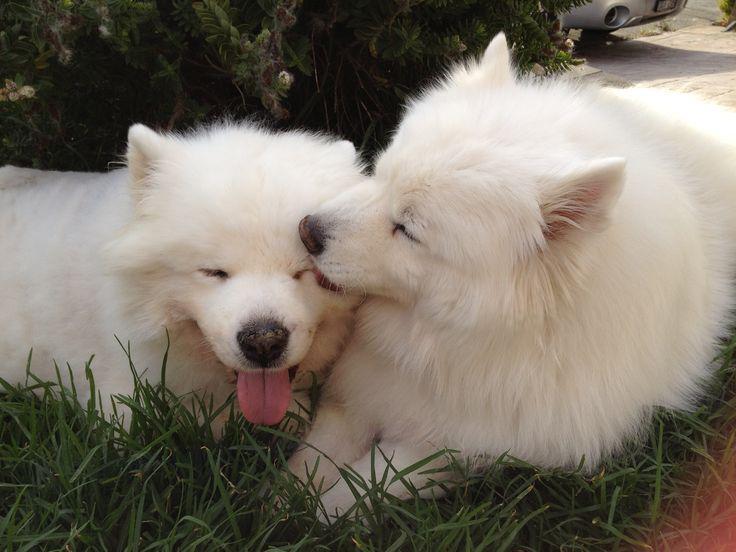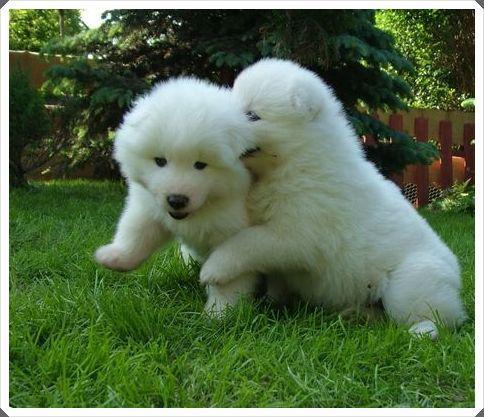The first image is the image on the left, the second image is the image on the right. Analyze the images presented: Is the assertion "Each image features two white dogs posed next to each other on green grass." valid? Answer yes or no. Yes. The first image is the image on the left, the second image is the image on the right. Given the left and right images, does the statement "There are two white dogs in each image that are roughly the same age." hold true? Answer yes or no. Yes. 